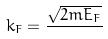Convert formula to latex. <formula><loc_0><loc_0><loc_500><loc_500>k _ { F } = \frac { \sqrt { 2 m E _ { F } } } { }</formula> 